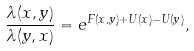Convert formula to latex. <formula><loc_0><loc_0><loc_500><loc_500>\frac { \lambda ( x , y ) } { \lambda ( y , x ) } = e ^ { F ( x , y ) + U ( x ) - U ( y ) } ,</formula> 